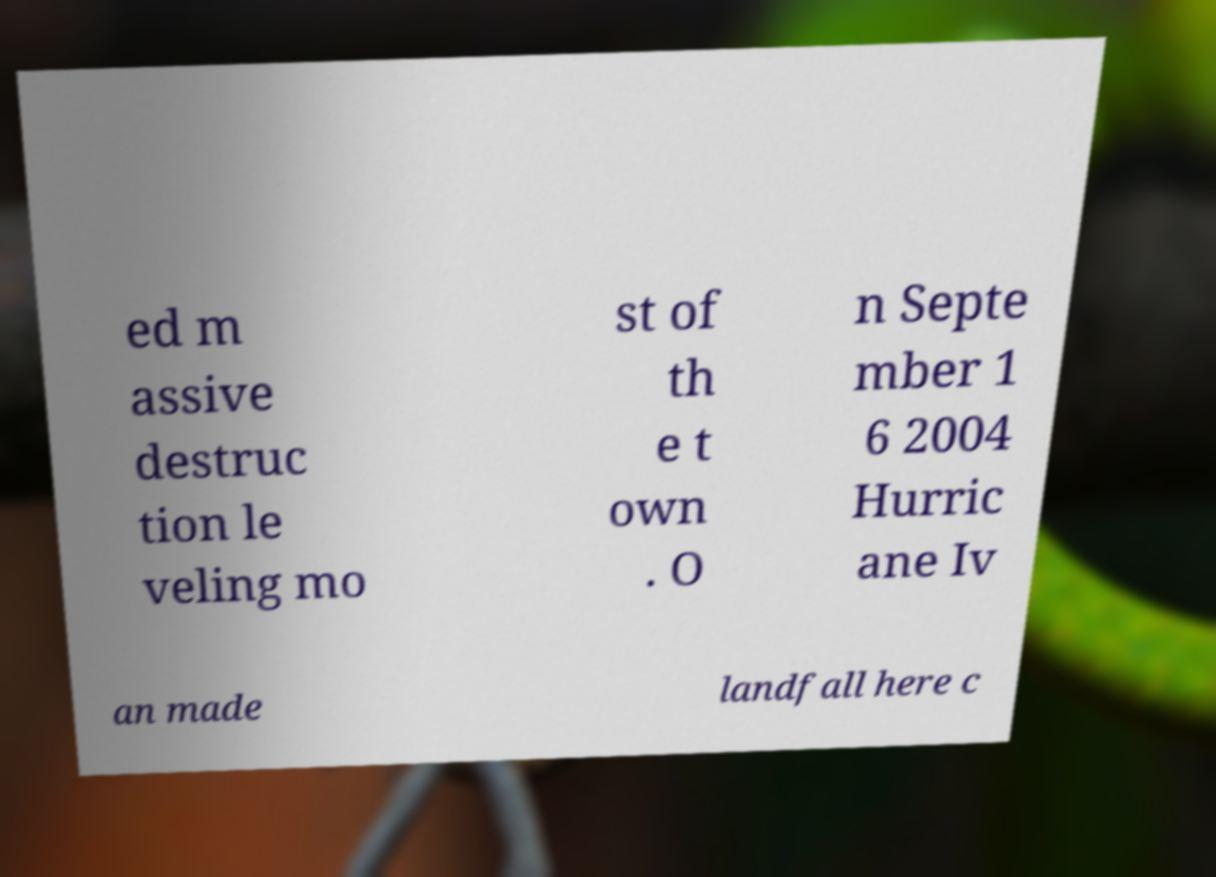What messages or text are displayed in this image? I need them in a readable, typed format. ed m assive destruc tion le veling mo st of th e t own . O n Septe mber 1 6 2004 Hurric ane Iv an made landfall here c 